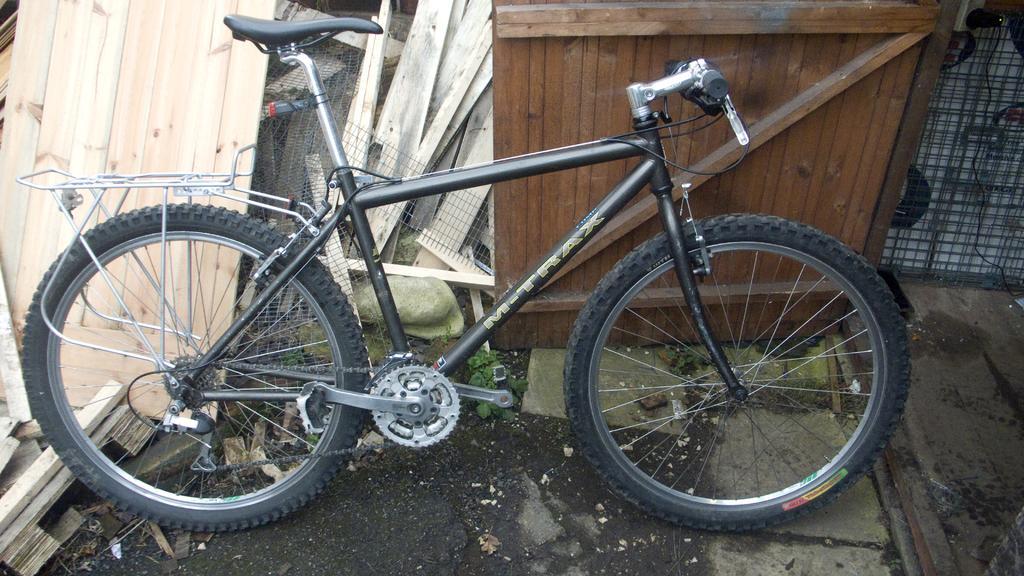In one or two sentences, can you explain what this image depicts? In the image we can see bicycle, mesh, cable wire and wooden sheets. 